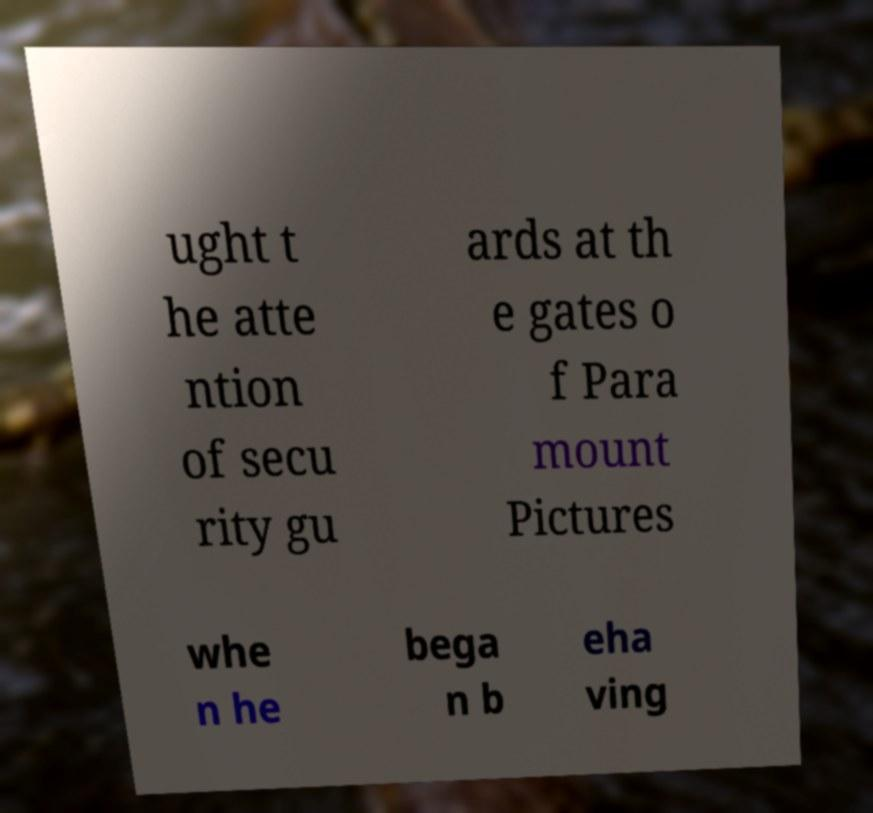Can you read and provide the text displayed in the image?This photo seems to have some interesting text. Can you extract and type it out for me? ught t he atte ntion of secu rity gu ards at th e gates o f Para mount Pictures whe n he bega n b eha ving 